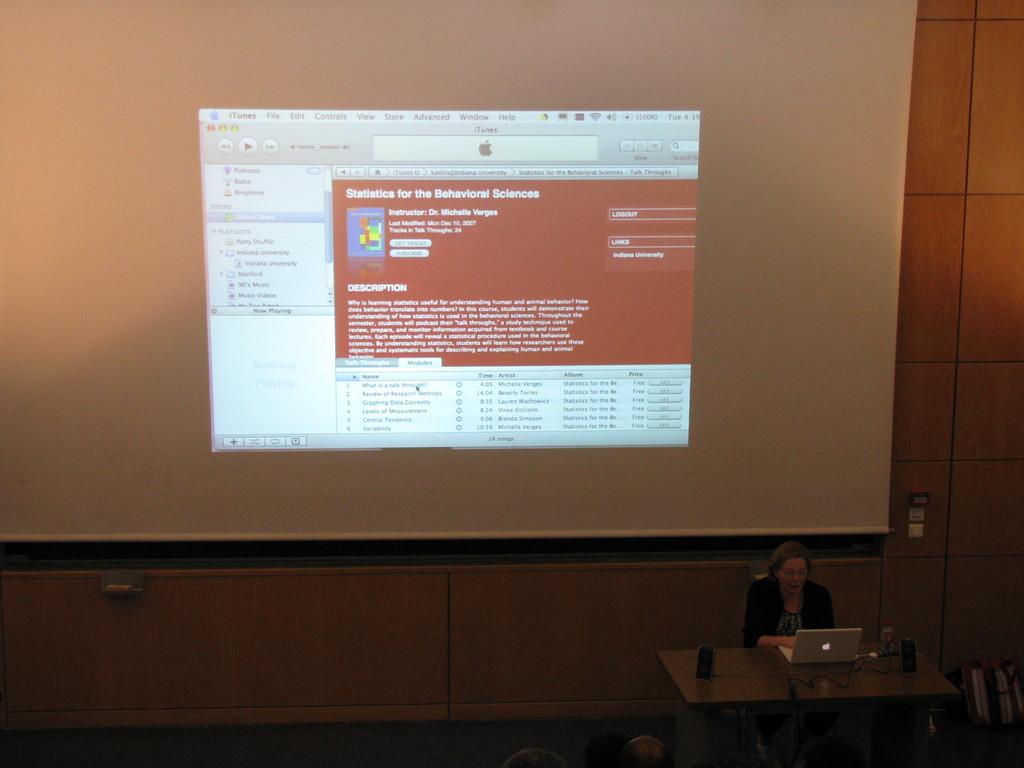What program is open on the screen?
Offer a terse response. Unanswerable. What class is being looked at?
Offer a very short reply. Statistics for the behavioral sciences. 